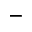<formula> <loc_0><loc_0><loc_500><loc_500>_ { - }</formula> 